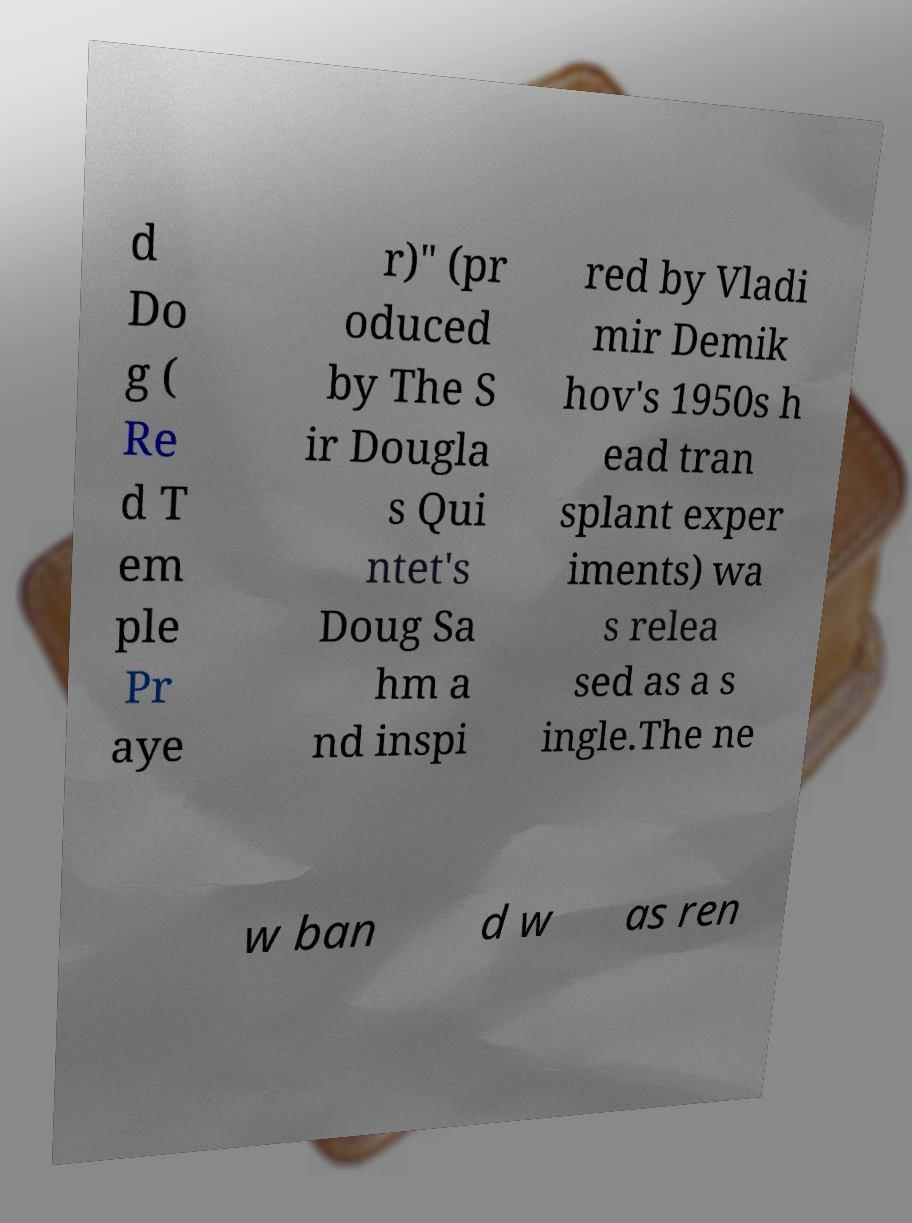I need the written content from this picture converted into text. Can you do that? d Do g ( Re d T em ple Pr aye r)" (pr oduced by The S ir Dougla s Qui ntet's Doug Sa hm a nd inspi red by Vladi mir Demik hov's 1950s h ead tran splant exper iments) wa s relea sed as a s ingle.The ne w ban d w as ren 